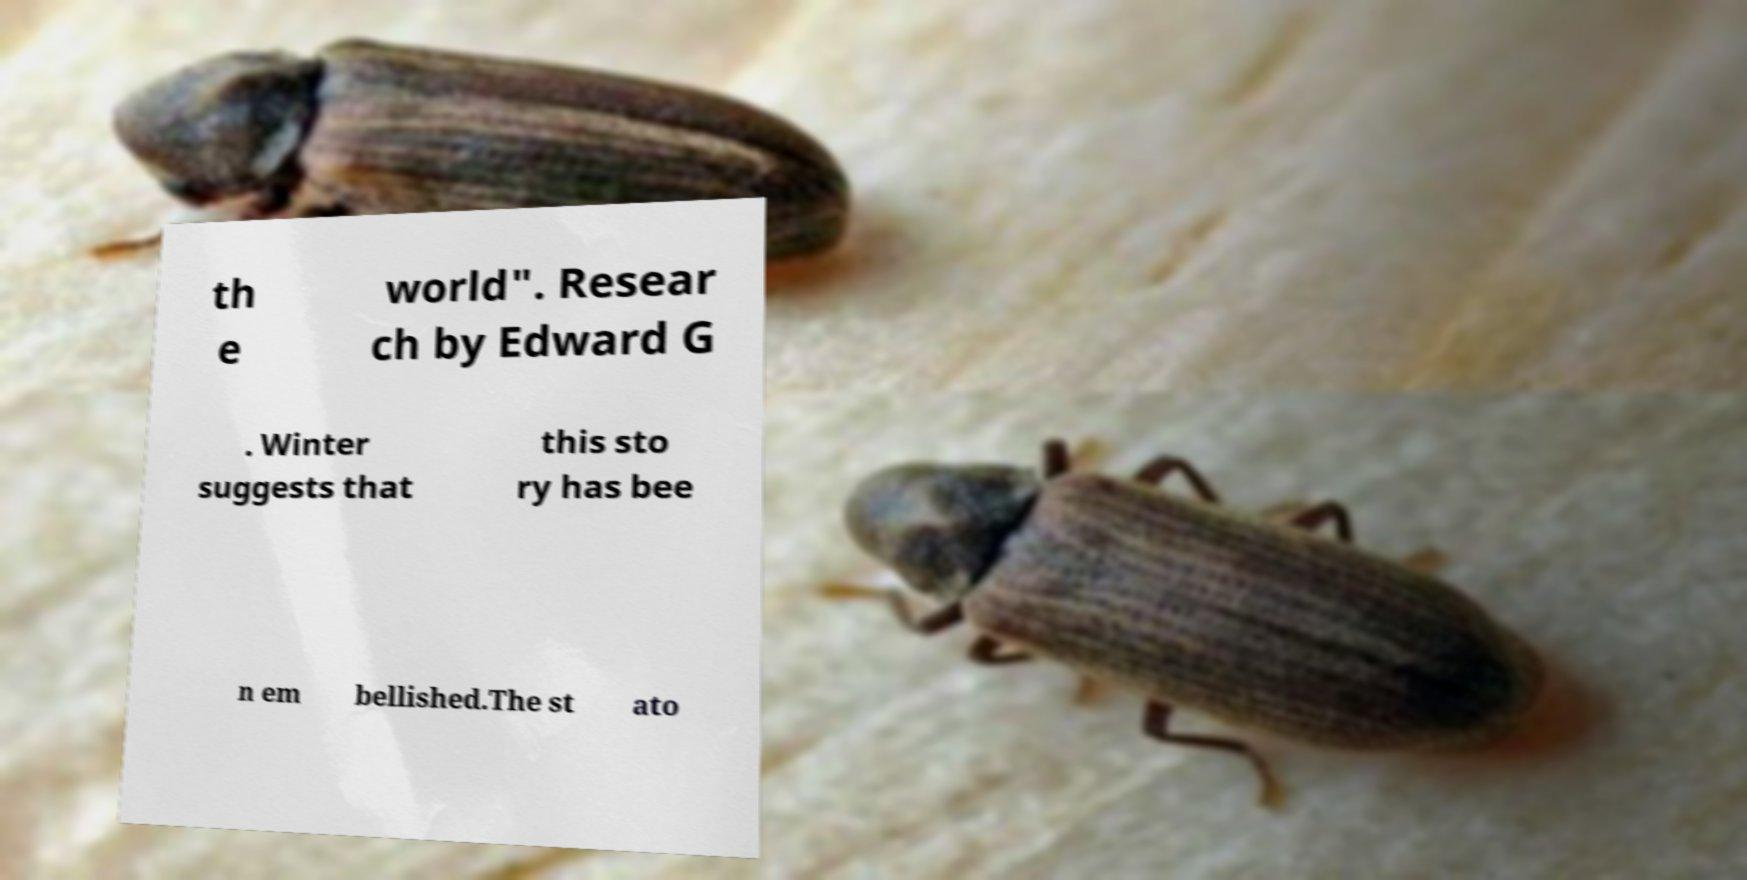There's text embedded in this image that I need extracted. Can you transcribe it verbatim? th e world". Resear ch by Edward G . Winter suggests that this sto ry has bee n em bellished.The st ato 